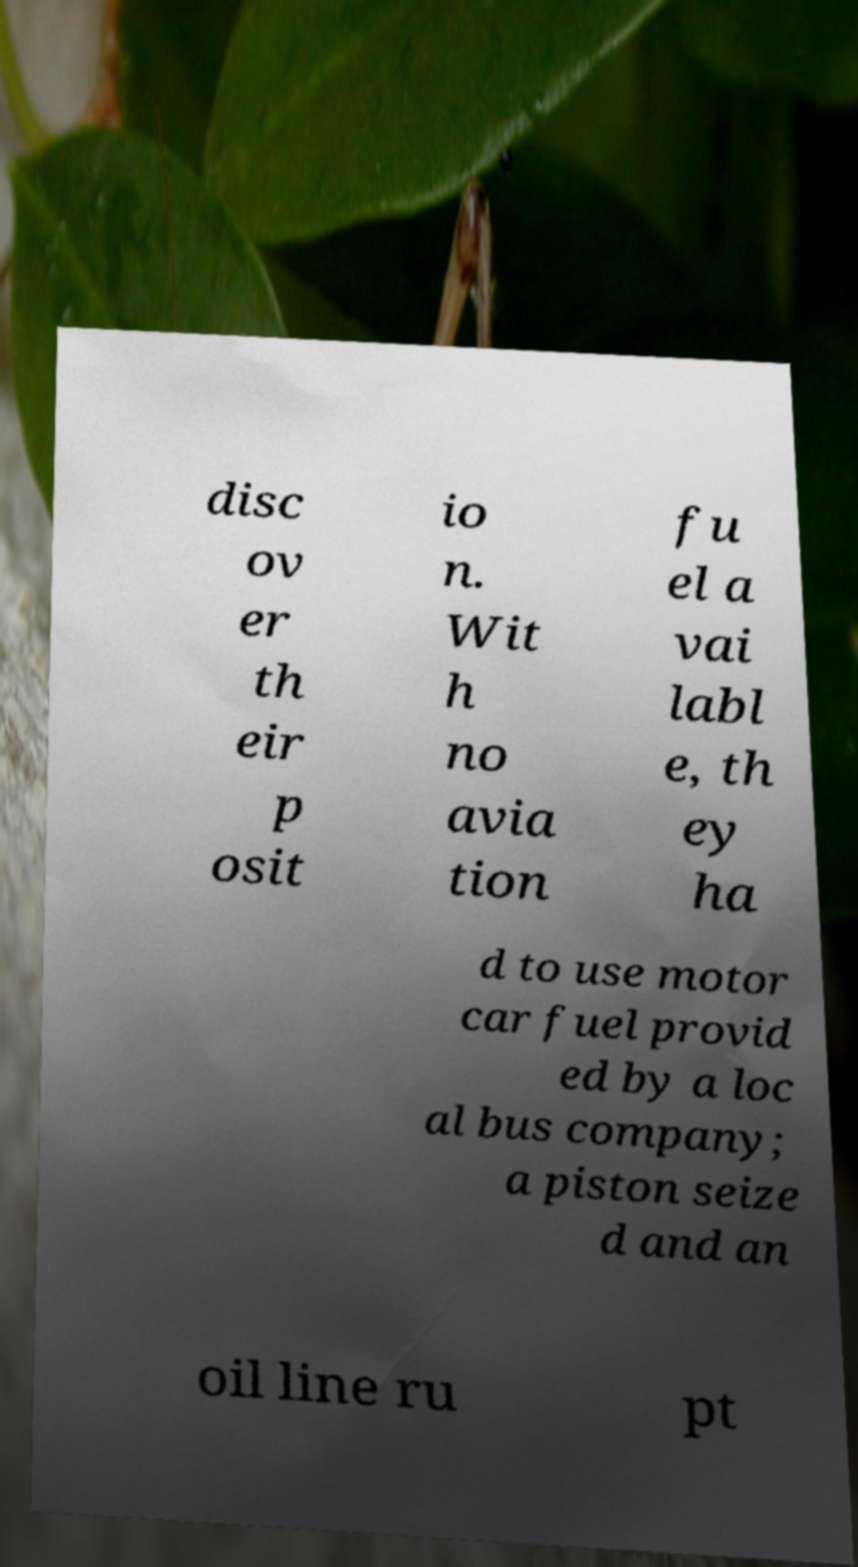Could you assist in decoding the text presented in this image and type it out clearly? disc ov er th eir p osit io n. Wit h no avia tion fu el a vai labl e, th ey ha d to use motor car fuel provid ed by a loc al bus company; a piston seize d and an oil line ru pt 